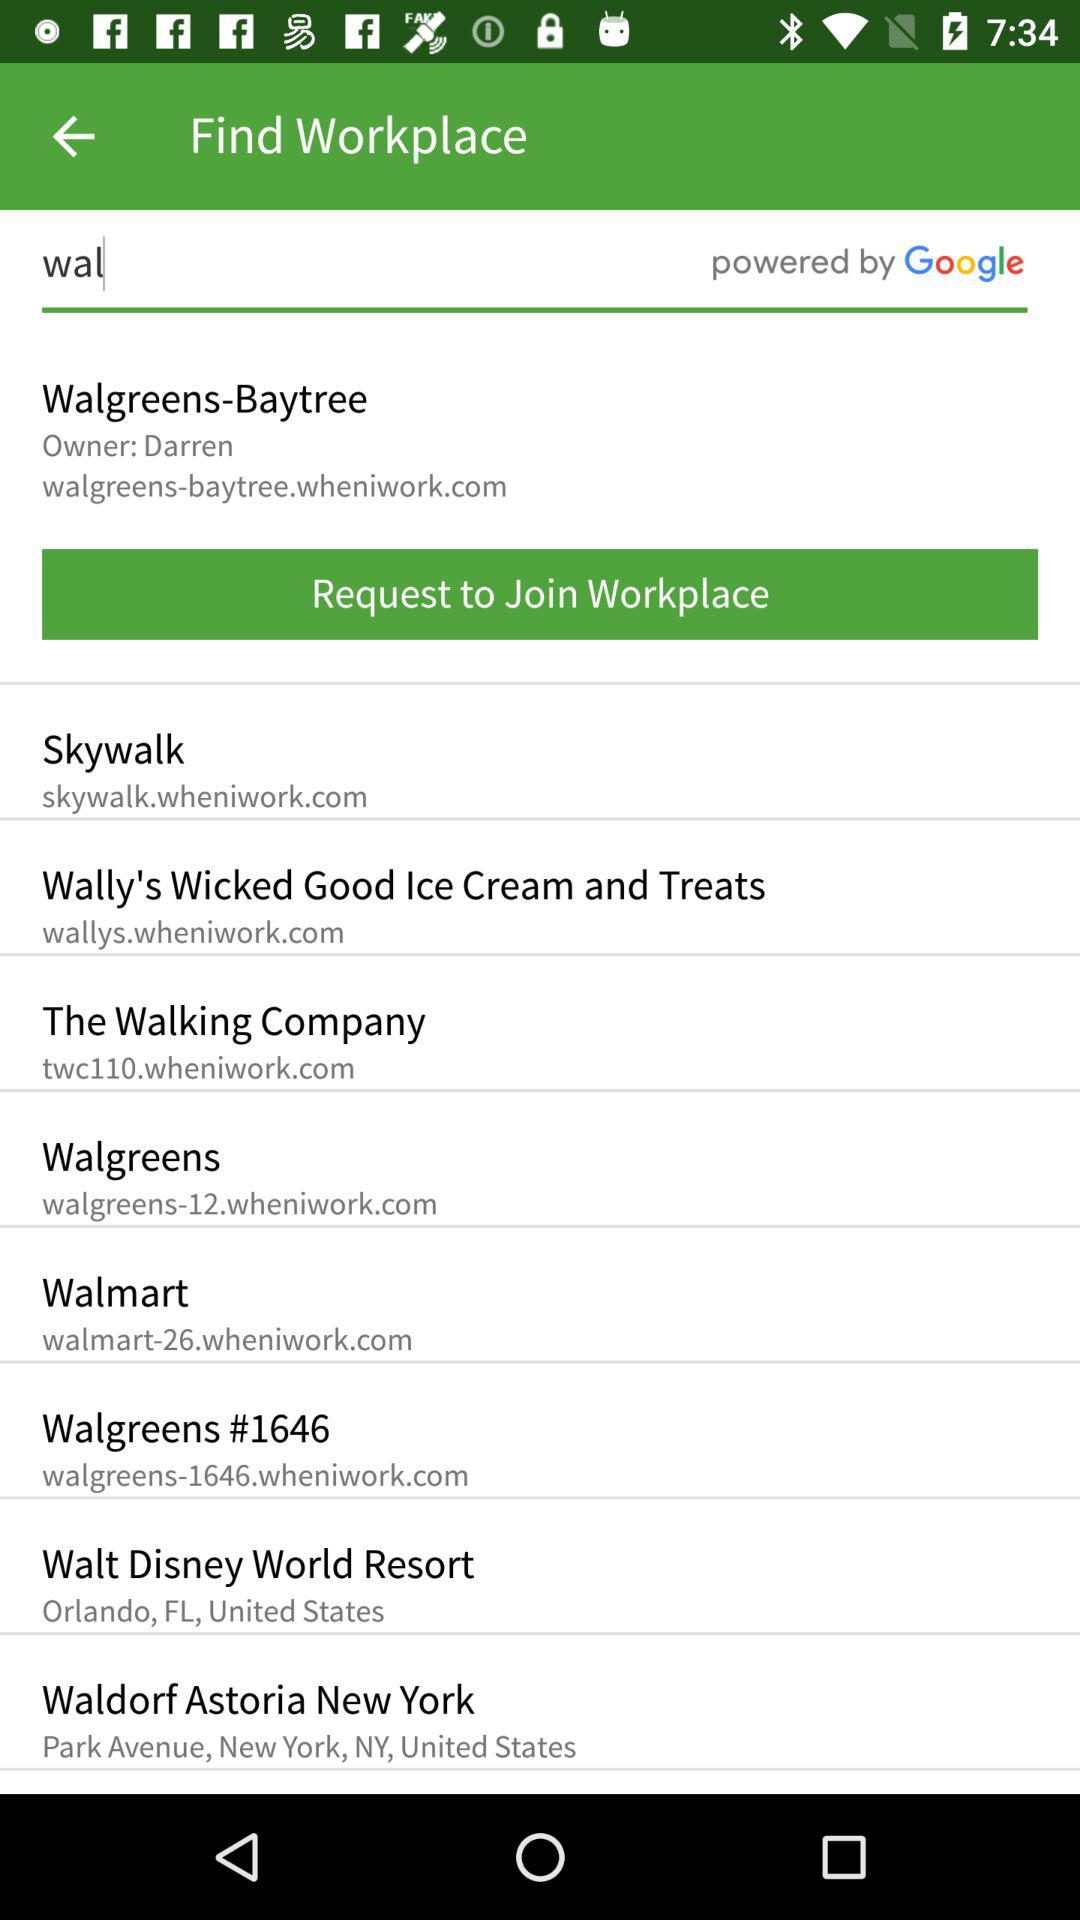What is the web site of "Walmart"? The web site is walmart-26.wheniwork.com. 